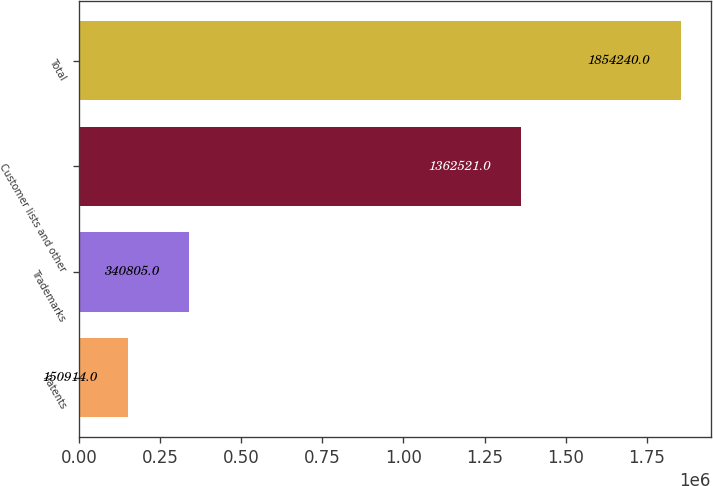<chart> <loc_0><loc_0><loc_500><loc_500><bar_chart><fcel>Patents<fcel>Trademarks<fcel>Customer lists and other<fcel>Total<nl><fcel>150914<fcel>340805<fcel>1.36252e+06<fcel>1.85424e+06<nl></chart> 